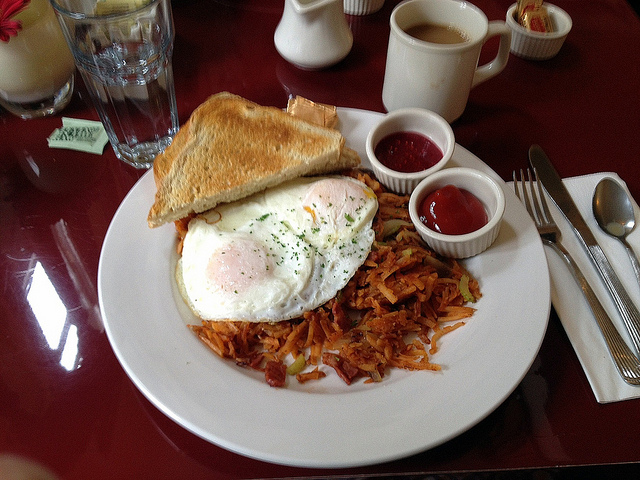What would happen if this breakfast were to be served at a grand royal banquet? If this humble yet delightful breakfast were to be presented at a grand royal banquet, it would surely surprise and delight the guests. Though simple in appearance, its quality and flavor would shine through, proving that even the most modest meals can stand out in luxurious settings. The freshly brewed coffee would be served in elegant porcelain cups, the toast perfectly crisped and garnished with artisanal butter and jams made from the finest fruits. The eggs would be prepared with meticulous attention, and the hash browns, golden and crispy, would be served with a variety of gourmet condiments. The royals and their guests would appreciate the honesty and craftsmanship of the meal, enjoying its heartwarming and satisfying flavors amidst opulent surroundings. An interesting twist on tradition! How might the chefs add a royal flair to it? To add a royal flair to this breakfast, the chefs could incorporate luxurious ingredients and exquisite presentation. The eggs could be topped with a sprinkle of truffle shavings or a delicate caviar garnish. The toast could be made from a fine brioche or artisan sourdough, served with house-made smoked salmon and a touch of crème fraîche. The hash browns might be enhanced with seasonal herbs and a drizzle of white truffle oil for an elegant touch. To accompany the meal, a fresh fruit platter with exotic fruits and a delicate herbal tea could be served alongside the traditional coffee. The final presentation would be on fine china with silver cutlery, transforming this simple breakfast into a meal fit for royalty. 